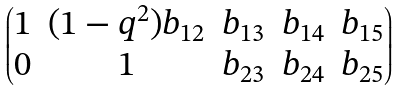Convert formula to latex. <formula><loc_0><loc_0><loc_500><loc_500>\begin{pmatrix} 1 & ( 1 - q ^ { 2 } ) b _ { 1 2 } & b _ { 1 3 } & b _ { 1 4 } & b _ { 1 5 } \\ 0 & 1 & b _ { 2 3 } & b _ { 2 4 } & b _ { 2 5 } \end{pmatrix}</formula> 